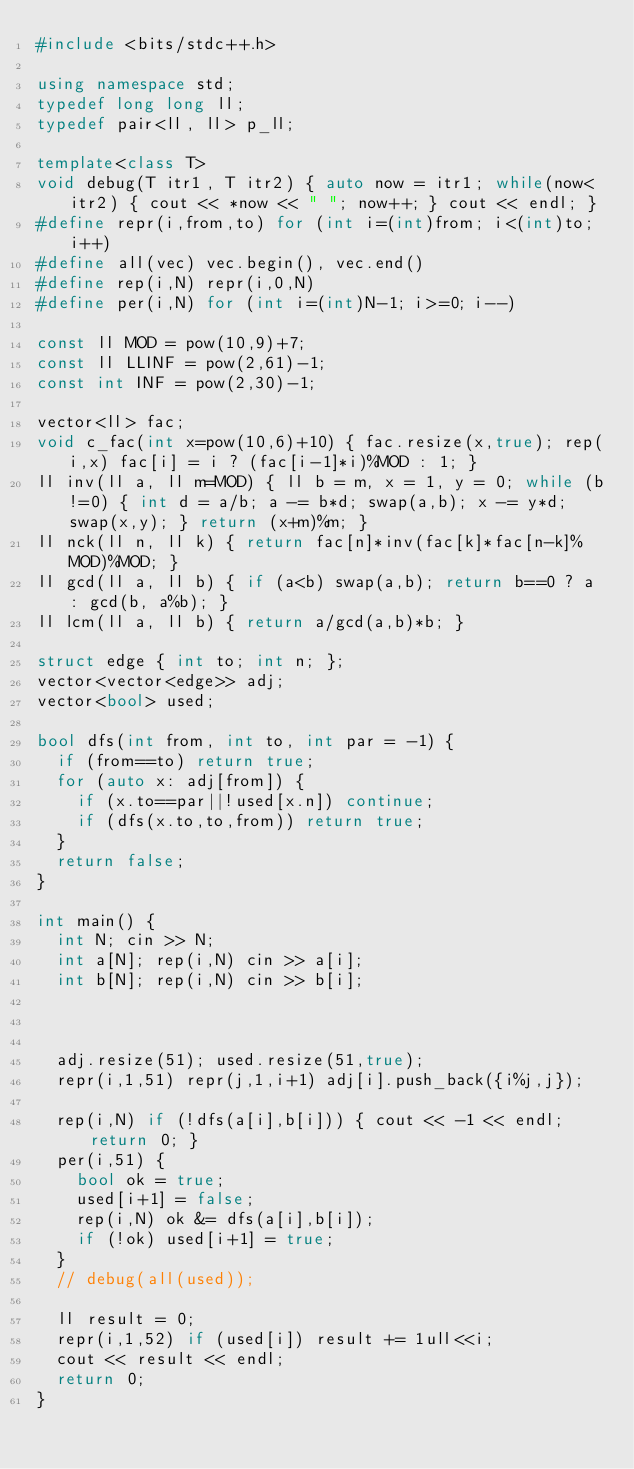Convert code to text. <code><loc_0><loc_0><loc_500><loc_500><_C++_>#include <bits/stdc++.h>

using namespace std;
typedef long long ll;
typedef pair<ll, ll> p_ll;

template<class T>
void debug(T itr1, T itr2) { auto now = itr1; while(now<itr2) { cout << *now << " "; now++; } cout << endl; }
#define repr(i,from,to) for (int i=(int)from; i<(int)to; i++)
#define all(vec) vec.begin(), vec.end()
#define rep(i,N) repr(i,0,N)
#define per(i,N) for (int i=(int)N-1; i>=0; i--)

const ll MOD = pow(10,9)+7;
const ll LLINF = pow(2,61)-1;
const int INF = pow(2,30)-1;

vector<ll> fac;
void c_fac(int x=pow(10,6)+10) { fac.resize(x,true); rep(i,x) fac[i] = i ? (fac[i-1]*i)%MOD : 1; }
ll inv(ll a, ll m=MOD) { ll b = m, x = 1, y = 0; while (b!=0) { int d = a/b; a -= b*d; swap(a,b); x -= y*d; swap(x,y); } return (x+m)%m; }
ll nck(ll n, ll k) { return fac[n]*inv(fac[k]*fac[n-k]%MOD)%MOD; }
ll gcd(ll a, ll b) { if (a<b) swap(a,b); return b==0 ? a : gcd(b, a%b); }
ll lcm(ll a, ll b) { return a/gcd(a,b)*b; }

struct edge { int to; int n; };
vector<vector<edge>> adj;
vector<bool> used;

bool dfs(int from, int to, int par = -1) {
  if (from==to) return true;
  for (auto x: adj[from]) {
    if (x.to==par||!used[x.n]) continue;
    if (dfs(x.to,to,from)) return true;
  }
  return false;
}

int main() {
  int N; cin >> N;
  int a[N]; rep(i,N) cin >> a[i];
  int b[N]; rep(i,N) cin >> b[i];



  adj.resize(51); used.resize(51,true);
  repr(i,1,51) repr(j,1,i+1) adj[i].push_back({i%j,j});

  rep(i,N) if (!dfs(a[i],b[i])) { cout << -1 << endl; return 0; }
  per(i,51) {
    bool ok = true;
    used[i+1] = false;
    rep(i,N) ok &= dfs(a[i],b[i]);
    if (!ok) used[i+1] = true;
  }
  // debug(all(used));

  ll result = 0;
  repr(i,1,52) if (used[i]) result += 1ull<<i;
  cout << result << endl;
  return 0;
}</code> 